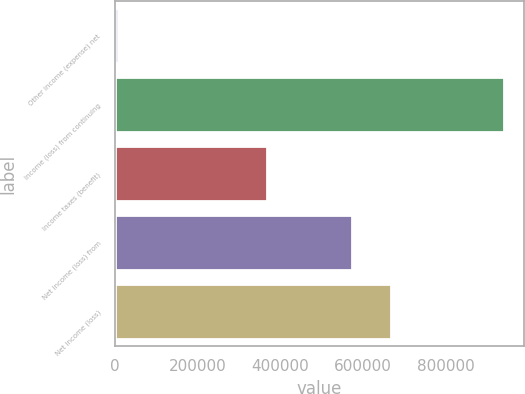Convert chart to OTSL. <chart><loc_0><loc_0><loc_500><loc_500><bar_chart><fcel>Other income (expense) net<fcel>Income (loss) from continuing<fcel>Income taxes (benefit)<fcel>Net income (loss) from<fcel>Net income (loss)<nl><fcel>6461<fcel>941090<fcel>367660<fcel>573430<fcel>666893<nl></chart> 